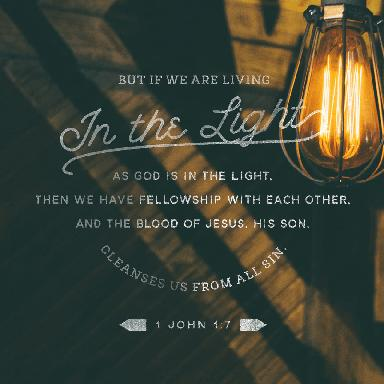Could this image be interpreted in more than one way? Certainly, while the primary interpretation relates to the biblical passage, there's also a more universal reading. It can be seen as a call to seek clarity and truth in one’s life, leaning towards wisdom and knowledge—themes that resonate beyond religious contexts. Light, universally, is a symbol of hope and guidance. What emotions might this image evoke in viewers? The image might evoke a sense of comfort and assurance due to the warm glow of the light bulb, representing hope and security. At the same time, it could inspire contemplation and introspection, as it prompts viewers to reflect on their own lives and whether they align with the 'light'—a metaphor for truth, goodness, or divine guidance. 